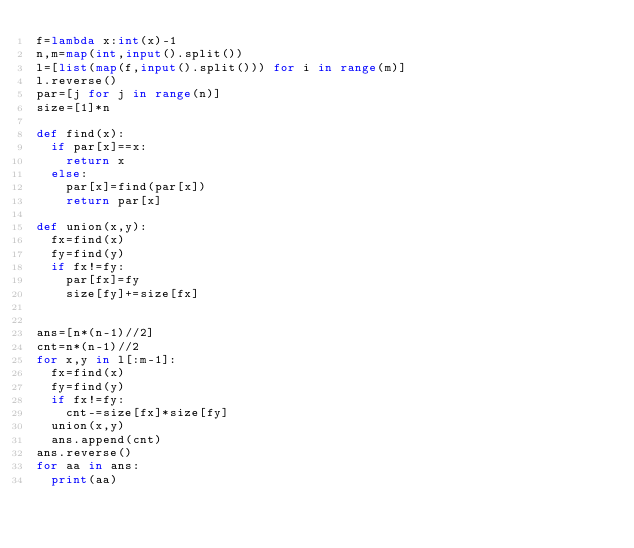<code> <loc_0><loc_0><loc_500><loc_500><_Python_>f=lambda x:int(x)-1
n,m=map(int,input().split())
l=[list(map(f,input().split())) for i in range(m)]
l.reverse()
par=[j for j in range(n)]
size=[1]*n

def find(x):
  if par[x]==x:
    return x
  else:
    par[x]=find(par[x])
    return par[x]
        
def union(x,y):
  fx=find(x)
  fy=find(y)
  if fx!=fy:
    par[fx]=fy
    size[fy]+=size[fx]


ans=[n*(n-1)//2]
cnt=n*(n-1)//2
for x,y in l[:m-1]:
  fx=find(x)
  fy=find(y)
  if fx!=fy:
    cnt-=size[fx]*size[fy]
  union(x,y)
  ans.append(cnt)
ans.reverse()
for aa in ans:
  print(aa)
</code> 